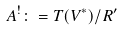<formula> <loc_0><loc_0><loc_500><loc_500>A ^ { ! } \colon = T ( V ^ { * } ) / R ^ { \prime }</formula> 